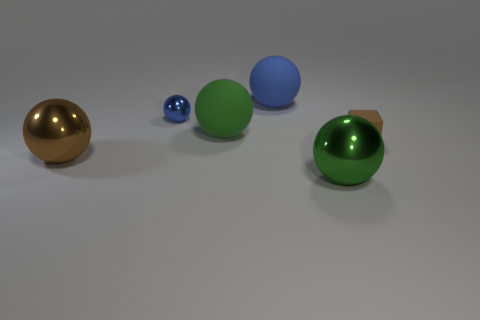There is another object that is the same color as the tiny metal thing; what shape is it?
Ensure brevity in your answer.  Sphere. What number of objects are either tiny yellow rubber cubes or large shiny things right of the large brown ball?
Offer a terse response. 1. There is a large thing that is both in front of the blue rubber ball and behind the large brown thing; what is its color?
Provide a succinct answer. Green. Does the blue rubber ball have the same size as the brown metal ball?
Offer a terse response. Yes. The rubber thing on the right side of the green metal thing is what color?
Your response must be concise. Brown. Is there a big metallic thing of the same color as the rubber block?
Offer a terse response. Yes. There is a matte sphere that is the same size as the blue rubber object; what color is it?
Your response must be concise. Green. Is the shape of the big brown thing the same as the large blue thing?
Your answer should be compact. Yes. What is the material of the green ball that is behind the block?
Give a very brief answer. Rubber. The small sphere has what color?
Keep it short and to the point. Blue. 